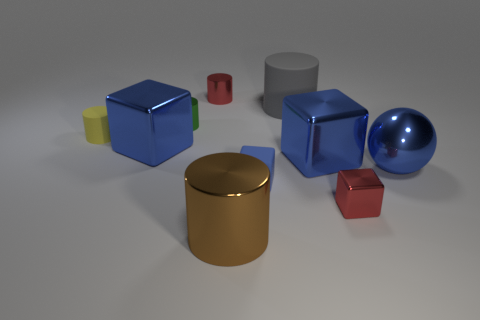What material is the green thing that is the same size as the yellow matte cylinder?
Keep it short and to the point. Metal. How many large things are red metallic cylinders or gray cubes?
Your answer should be very brief. 0. How many objects are tiny objects right of the small yellow matte cylinder or big things that are behind the brown shiny cylinder?
Ensure brevity in your answer.  8. Is the number of tiny blue cylinders less than the number of large matte cylinders?
Your response must be concise. Yes. What is the shape of the matte thing that is the same size as the brown metal object?
Ensure brevity in your answer.  Cylinder. What number of other objects are there of the same color as the big rubber thing?
Your response must be concise. 0. What number of small yellow balls are there?
Offer a very short reply. 0. What number of metallic things are both on the right side of the green cylinder and on the left side of the metal ball?
Offer a very short reply. 4. What is the material of the tiny blue block?
Offer a terse response. Rubber. Are any small red metal blocks visible?
Ensure brevity in your answer.  Yes. 